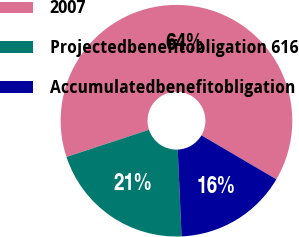Convert chart. <chart><loc_0><loc_0><loc_500><loc_500><pie_chart><fcel>2007<fcel>Projectedbenefitobligation 616<fcel>Accumulatedbenefitobligation<nl><fcel>63.51%<fcel>20.63%<fcel>15.86%<nl></chart> 